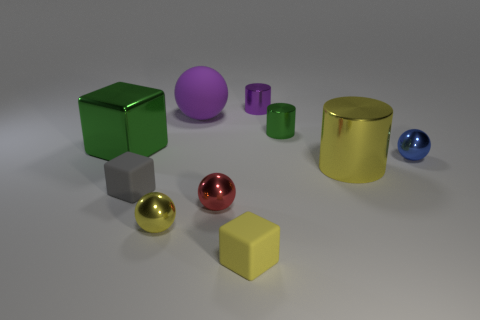There is a rubber object that is the same shape as the small red shiny object; what is its color?
Provide a short and direct response. Purple. Is the size of the block that is in front of the gray rubber cube the same as the purple sphere?
Your answer should be very brief. No. The thing that is the same color as the big metallic cube is what shape?
Give a very brief answer. Cylinder. How many large purple balls are made of the same material as the yellow block?
Provide a short and direct response. 1. The large thing to the left of the matte object that is behind the tiny shiny sphere that is behind the large yellow cylinder is made of what material?
Your answer should be compact. Metal. There is a matte cube in front of the tiny metallic thing that is left of the large purple rubber ball; what color is it?
Your answer should be compact. Yellow. There is a block that is the same size as the gray object; what is its color?
Ensure brevity in your answer.  Yellow. How many small objects are purple rubber things or yellow objects?
Keep it short and to the point. 2. Is the number of small spheres to the right of the small red metallic sphere greater than the number of yellow matte blocks that are behind the big shiny cylinder?
Make the answer very short. Yes. The cylinder that is the same color as the matte sphere is what size?
Provide a short and direct response. Small. 